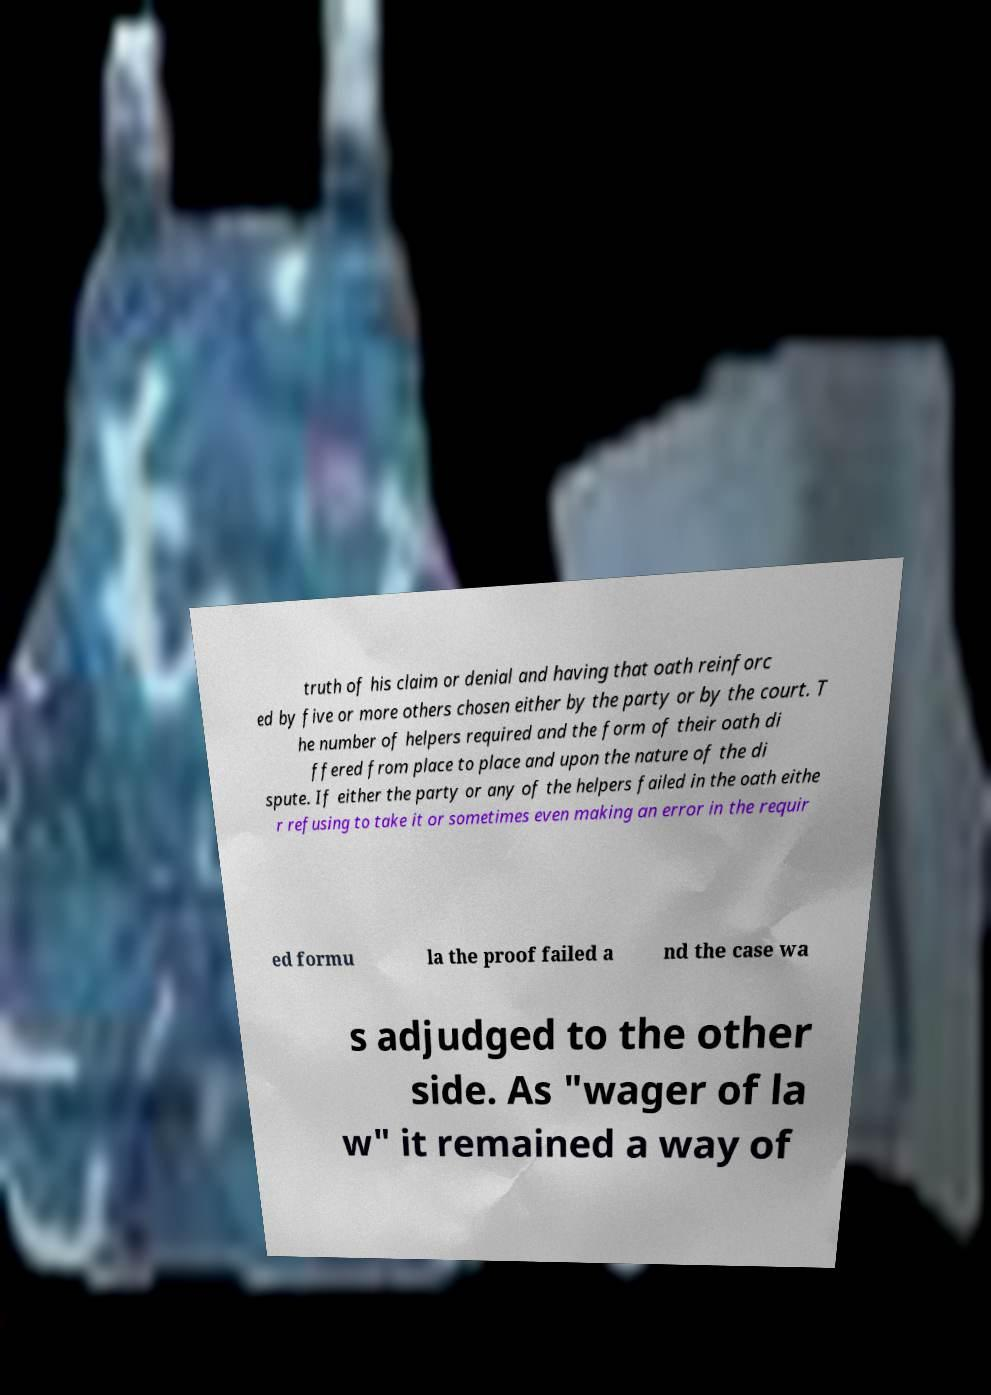Could you assist in decoding the text presented in this image and type it out clearly? truth of his claim or denial and having that oath reinforc ed by five or more others chosen either by the party or by the court. T he number of helpers required and the form of their oath di ffered from place to place and upon the nature of the di spute. If either the party or any of the helpers failed in the oath eithe r refusing to take it or sometimes even making an error in the requir ed formu la the proof failed a nd the case wa s adjudged to the other side. As "wager of la w" it remained a way of 